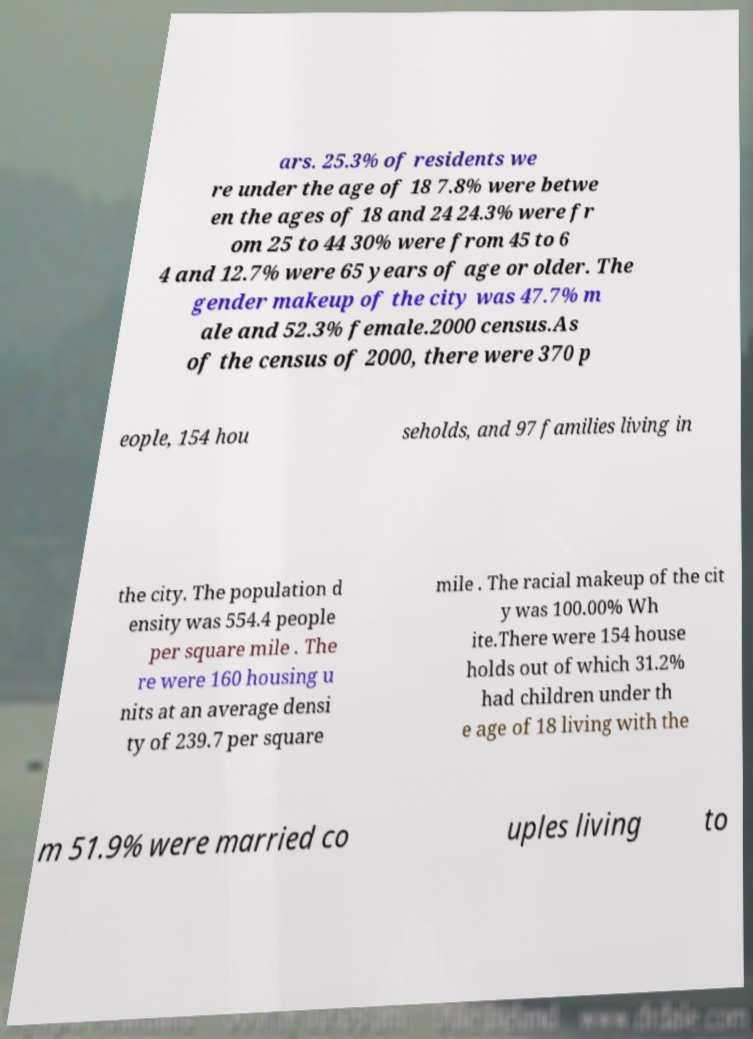Could you assist in decoding the text presented in this image and type it out clearly? ars. 25.3% of residents we re under the age of 18 7.8% were betwe en the ages of 18 and 24 24.3% were fr om 25 to 44 30% were from 45 to 6 4 and 12.7% were 65 years of age or older. The gender makeup of the city was 47.7% m ale and 52.3% female.2000 census.As of the census of 2000, there were 370 p eople, 154 hou seholds, and 97 families living in the city. The population d ensity was 554.4 people per square mile . The re were 160 housing u nits at an average densi ty of 239.7 per square mile . The racial makeup of the cit y was 100.00% Wh ite.There were 154 house holds out of which 31.2% had children under th e age of 18 living with the m 51.9% were married co uples living to 